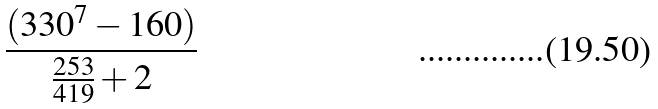Convert formula to latex. <formula><loc_0><loc_0><loc_500><loc_500>\frac { ( 3 3 0 ^ { 7 } - 1 6 0 ) } { \frac { 2 5 3 } { 4 1 9 } + 2 }</formula> 